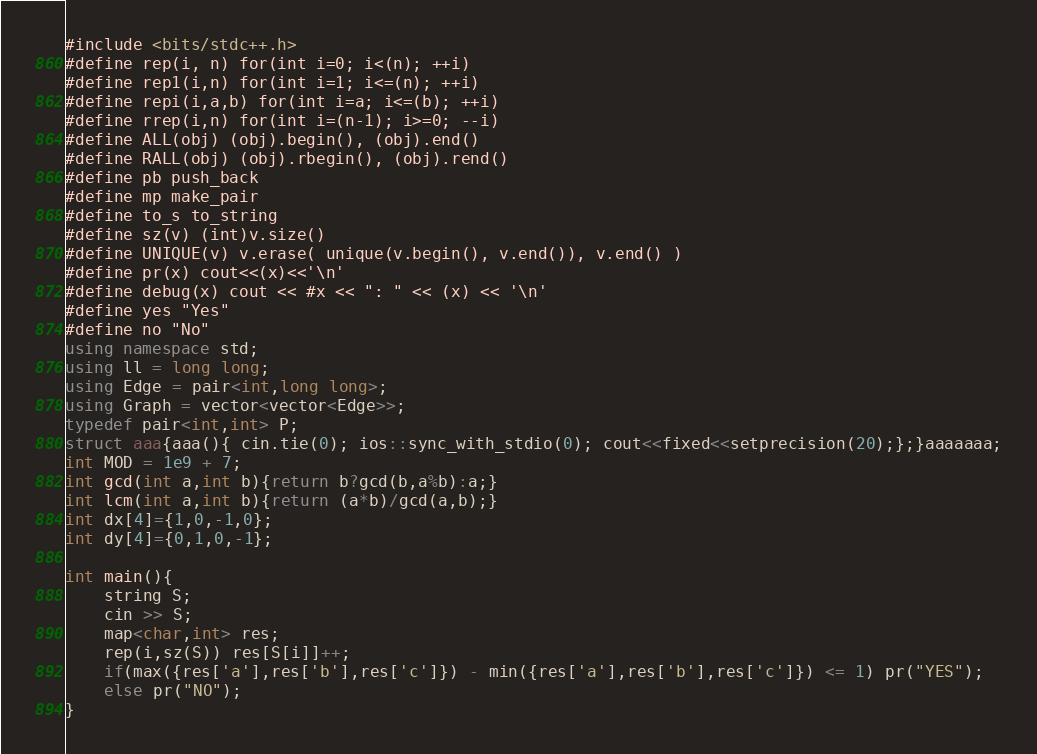<code> <loc_0><loc_0><loc_500><loc_500><_C++_>#include <bits/stdc++.h>
#define rep(i, n) for(int i=0; i<(n); ++i)
#define rep1(i,n) for(int i=1; i<=(n); ++i)
#define repi(i,a,b) for(int i=a; i<=(b); ++i)
#define rrep(i,n) for(int i=(n-1); i>=0; --i)
#define ALL(obj) (obj).begin(), (obj).end()
#define RALL(obj) (obj).rbegin(), (obj).rend()
#define pb push_back
#define mp make_pair
#define to_s to_string
#define sz(v) (int)v.size()
#define UNIQUE(v) v.erase( unique(v.begin(), v.end()), v.end() )
#define pr(x) cout<<(x)<<'\n'
#define debug(x) cout << #x << ": " << (x) << '\n'
#define yes "Yes"
#define no "No"
using namespace std;
using ll = long long;
using Edge = pair<int,long long>;
using Graph = vector<vector<Edge>>;
typedef pair<int,int> P;
struct aaa{aaa(){ cin.tie(0); ios::sync_with_stdio(0); cout<<fixed<<setprecision(20);};}aaaaaaa;
int MOD = 1e9 + 7;
int gcd(int a,int b){return b?gcd(b,a%b):a;}
int lcm(int a,int b){return (a*b)/gcd(a,b);}
int dx[4]={1,0,-1,0};
int dy[4]={0,1,0,-1};

int main(){
    string S;
    cin >> S;
    map<char,int> res;
    rep(i,sz(S)) res[S[i]]++;
    if(max({res['a'],res['b'],res['c']}) - min({res['a'],res['b'],res['c']}) <= 1) pr("YES");
    else pr("NO");
}</code> 